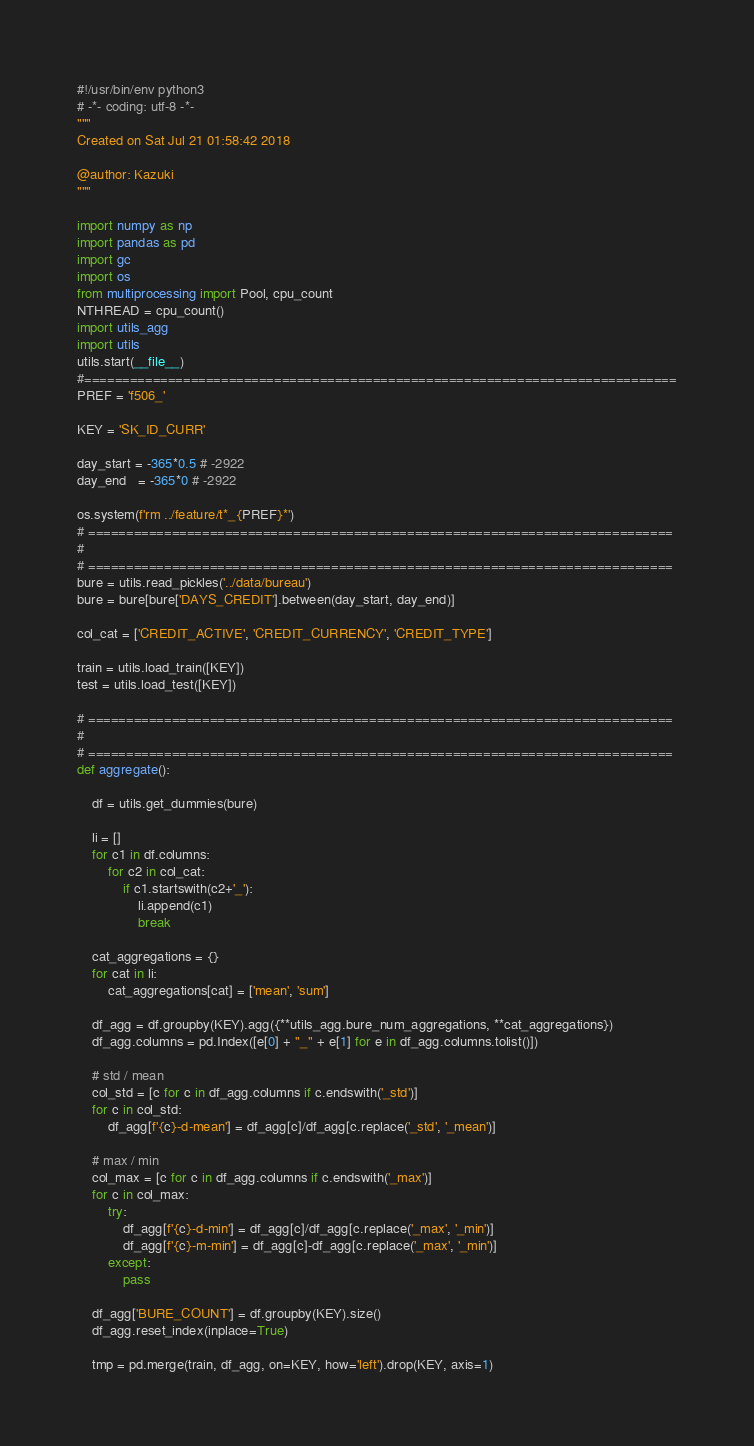<code> <loc_0><loc_0><loc_500><loc_500><_Python_>#!/usr/bin/env python3
# -*- coding: utf-8 -*-
"""
Created on Sat Jul 21 01:58:42 2018

@author: Kazuki
"""

import numpy as np
import pandas as pd
import gc
import os
from multiprocessing import Pool, cpu_count
NTHREAD = cpu_count()
import utils_agg
import utils
utils.start(__file__)
#==============================================================================
PREF = 'f506_'

KEY = 'SK_ID_CURR'

day_start = -365*0.5 # -2922
day_end   = -365*0 # -2922

os.system(f'rm ../feature/t*_{PREF}*')
# =============================================================================
# 
# =============================================================================
bure = utils.read_pickles('../data/bureau')
bure = bure[bure['DAYS_CREDIT'].between(day_start, day_end)]

col_cat = ['CREDIT_ACTIVE', 'CREDIT_CURRENCY', 'CREDIT_TYPE']

train = utils.load_train([KEY])
test = utils.load_test([KEY])

# =============================================================================
# 
# =============================================================================
def aggregate():
    
    df = utils.get_dummies(bure)
    
    li = []
    for c1 in df.columns:
        for c2 in col_cat:
            if c1.startswith(c2+'_'):
                li.append(c1)
                break
    
    cat_aggregations = {}
    for cat in li:
        cat_aggregations[cat] = ['mean', 'sum']
    
    df_agg = df.groupby(KEY).agg({**utils_agg.bure_num_aggregations, **cat_aggregations})
    df_agg.columns = pd.Index([e[0] + "_" + e[1] for e in df_agg.columns.tolist()])
    
    # std / mean
    col_std = [c for c in df_agg.columns if c.endswith('_std')]
    for c in col_std:
        df_agg[f'{c}-d-mean'] = df_agg[c]/df_agg[c.replace('_std', '_mean')]
    
    # max / min
    col_max = [c for c in df_agg.columns if c.endswith('_max')]
    for c in col_max:
        try:
            df_agg[f'{c}-d-min'] = df_agg[c]/df_agg[c.replace('_max', '_min')]
            df_agg[f'{c}-m-min'] = df_agg[c]-df_agg[c.replace('_max', '_min')]
        except:
            pass
    
    df_agg['BURE_COUNT'] = df.groupby(KEY).size()
    df_agg.reset_index(inplace=True)
    
    tmp = pd.merge(train, df_agg, on=KEY, how='left').drop(KEY, axis=1)</code> 